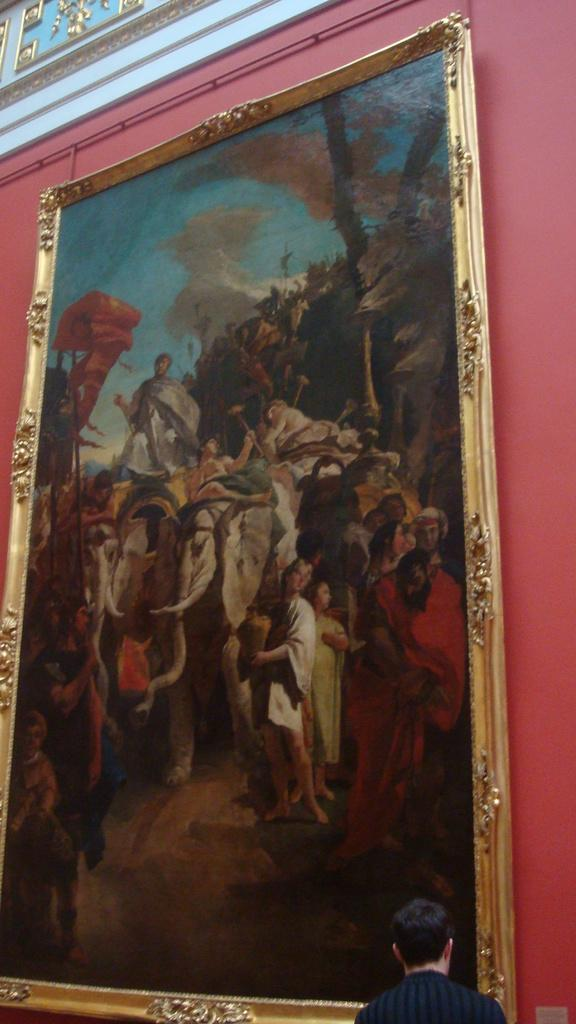What is located in the center of the image on the wall? There is a photo frame in the center of the image on the wall. Can you describe the person at the bottom of the image? There is a person at the bottom of the image, but their appearance or actions are not specified. What is located at the top of the image? There is a board at the top of the image. How does the person at the bottom of the image gain knowledge in the image? There is no information provided about the person gaining knowledge in the image. What type of rest can be seen in the image? There is no rest visible in the image. 